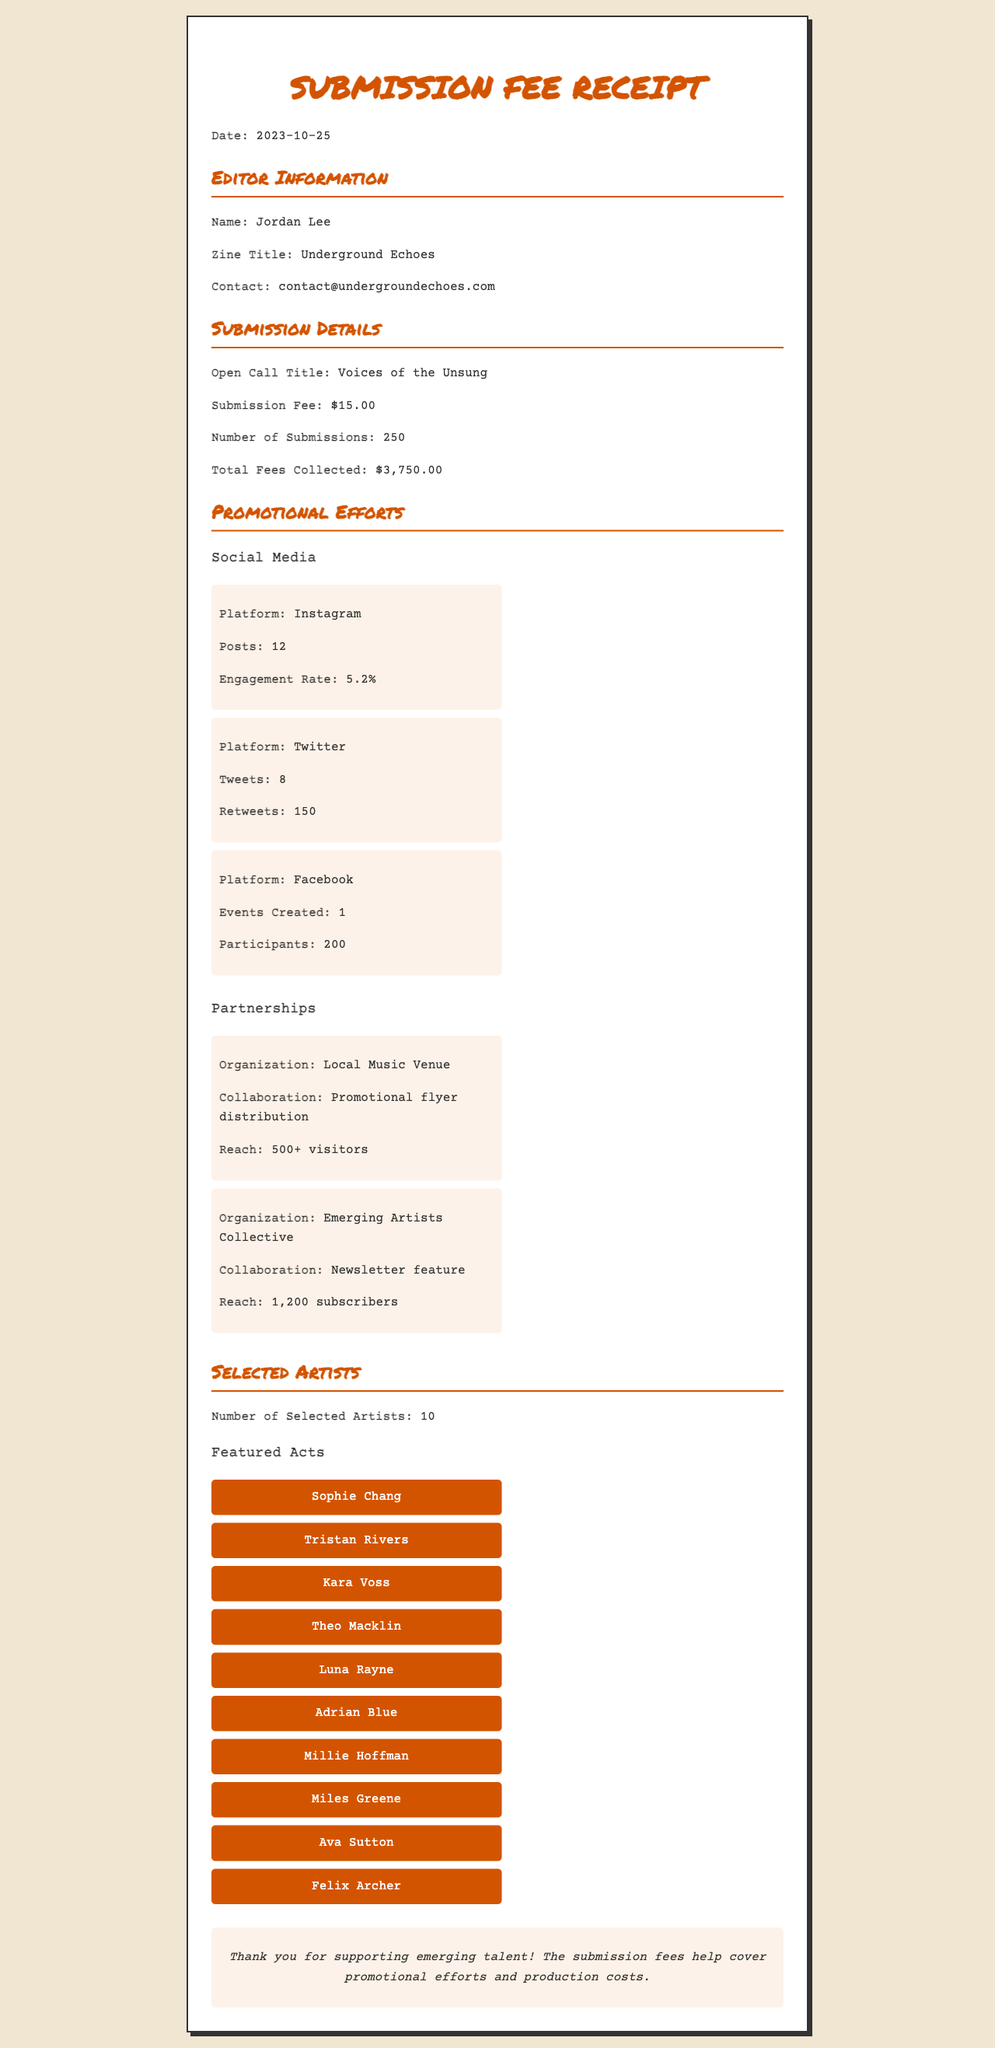what is the date of the receipt? The date is mentioned prominently in the document as the issuance date.
Answer: 2023-10-25 who is the editor of the zine? The editor's name is listed in the editor information section of the document.
Answer: Jordan Lee what is the submission fee for the open call? The submission fee is clearly stated in the submission details part of the receipt.
Answer: $15.00 how many submissions were received? The number of submissions is provided in the submission details section.
Answer: 250 what is the total amount collected from submission fees? The total fees collected is a key detail found in the submission details section.
Answer: $3,750.00 how many artists were selected for the event? The number of selected artists is explicitly mentioned in the selected artists section.
Answer: 10 which platform had the highest engagement rate? The engagement rate for different social media platforms is compared to determine which is highest.
Answer: Instagram what type of collaboration did the Emerging Artists Collective provide? The type of collaboration is specified under the partnerships section of the document.
Answer: Newsletter feature what is the title of the open call? The title of the open call is stated in the submission details section.
Answer: Voices of the Unsung 